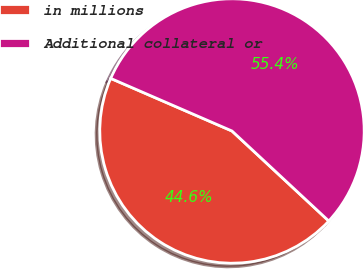<chart> <loc_0><loc_0><loc_500><loc_500><pie_chart><fcel>in millions<fcel>Additional collateral or<nl><fcel>44.59%<fcel>55.41%<nl></chart> 